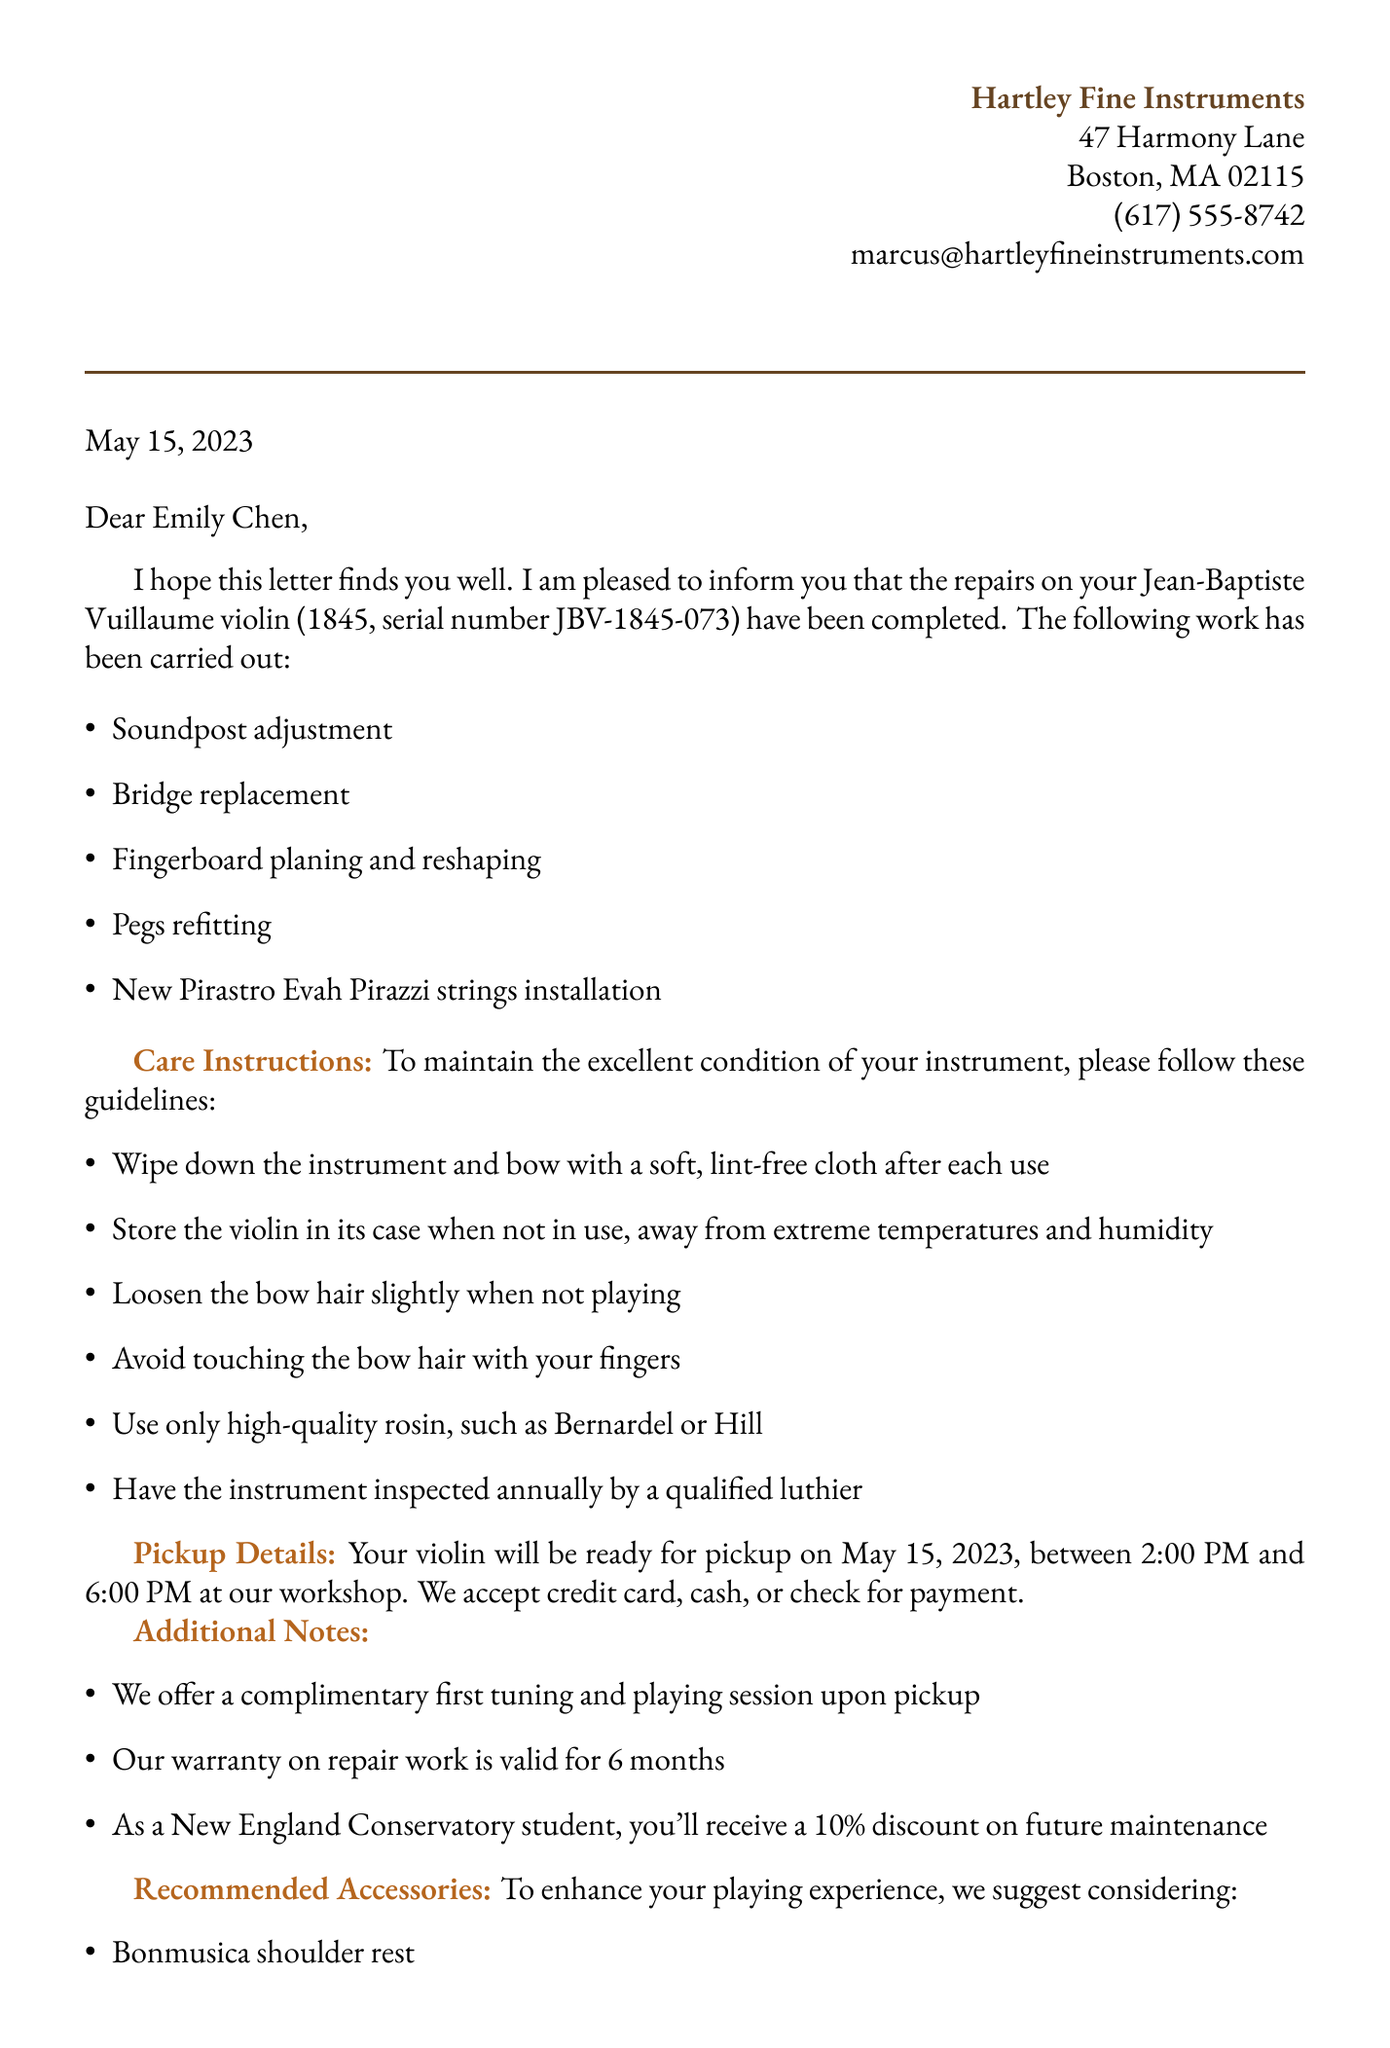What is the name of the luthier? The name of the luthier is mentioned in the letter's signature, which states Marcus Hartley.
Answer: Marcus Hartley What year was the violin made? The year of the violin is provided in the detail section as 1845.
Answer: 1845 What type of strings were installed on the violin? The letter lists the newly installed strings as Pirastro Evah Pirazzi.
Answer: Pirastro Evah Pirazzi When can the student pick up the violin? The pickup date is clearly stated in the pickup details as May 15, 2023.
Answer: May 15, 2023 What is one of the care instructions provided? One of the care instructions is to "Wipe down the instrument and bow with a soft, lint-free cloth after each use."
Answer: Wipe down the instrument and bow What warranty is provided for the repair work? The warranty period for the repair work is specifically stated in the additional notes as valid for 6 months.
Answer: 6 months What is the location for the violin pickup? The document specifies Hartley Fine Instruments workshop as the pickup location.
Answer: Hartley Fine Instruments workshop What discount do New England Conservatory students receive? The letter states that New England Conservatory students receive a 10% discount on future maintenance.
Answer: 10% discount 